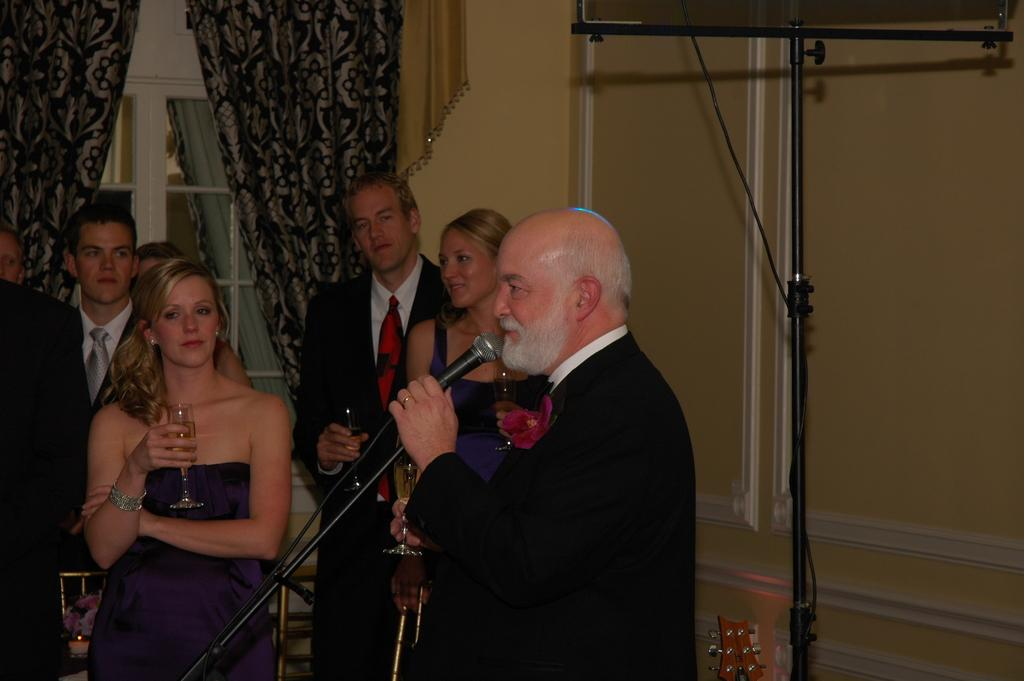What is the man in the image holding? The man is holding a microphone. What are the other persons in the image doing? The other persons in the image are standing. What is a feature in the background of the image? There is a curtain in the image. What architectural element is present in the image? There is a door in the image. What type of turkey can be seen in the image? There is no turkey present in the image. How are the persons in the image being transported? The persons in the image are not being transported; they are standing in place. What time of day is it in the image, as indicated by the presence of clocks? There is no mention of clocks in the image, so it cannot be determined from the image what time of day it is. 